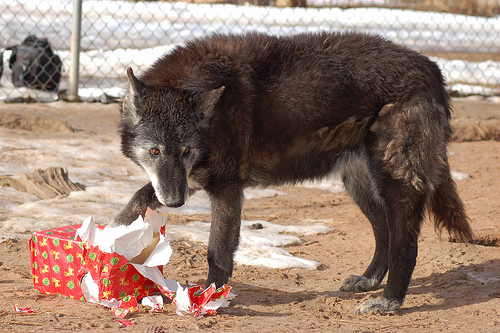<image>
Is the wolf on the present? Yes. Looking at the image, I can see the wolf is positioned on top of the present, with the present providing support. 